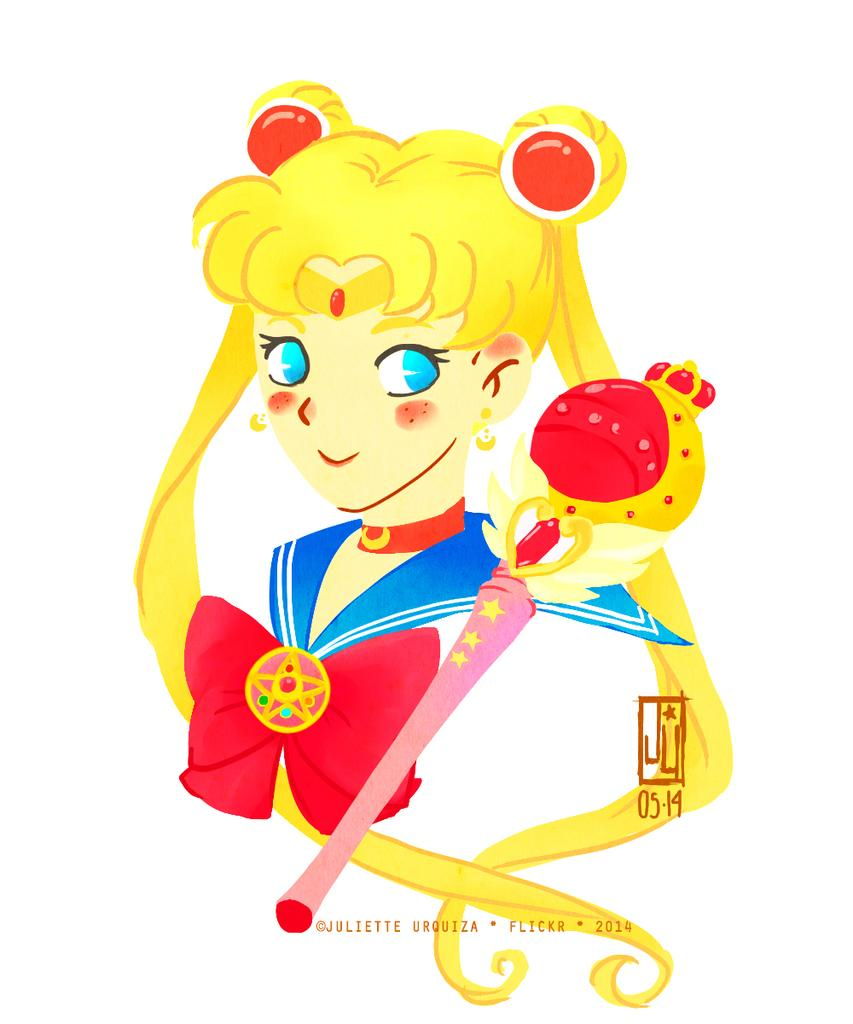What type of image is in the picture? There is a cartoon image of a girl in the picture. What accessory is visible in the picture? There is a bow tie in the picture. What object is present in the picture that could be used as a tool or weapon? There is a stick in the picture. What can be found in the picture besides the cartoon image? There is some text in the picture. What color is the background of the image? The background of the image is white. What type of toy can be seen being played with on the playground in the image? There is no toy or playground present in the image; it features a cartoon image of a girl, a bow tie, a stick, text, and a white background. 